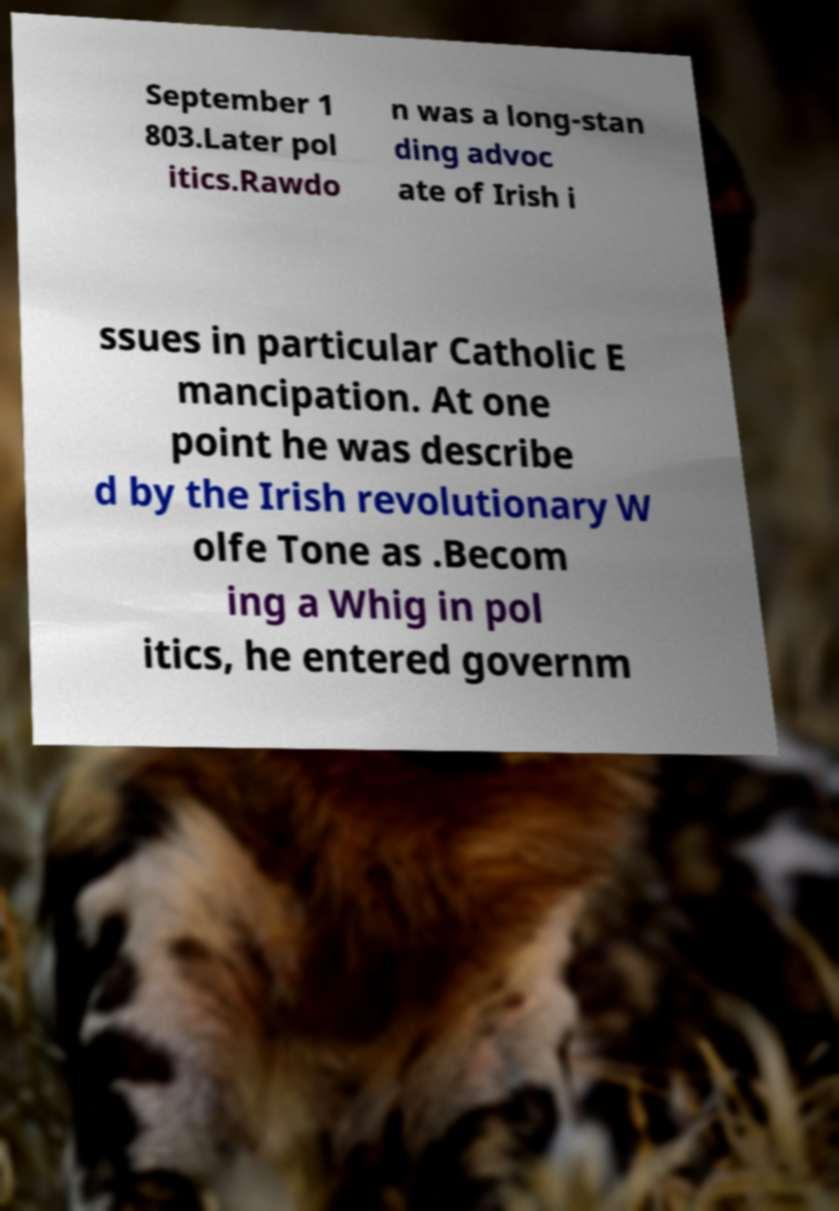For documentation purposes, I need the text within this image transcribed. Could you provide that? September 1 803.Later pol itics.Rawdo n was a long-stan ding advoc ate of Irish i ssues in particular Catholic E mancipation. At one point he was describe d by the Irish revolutionary W olfe Tone as .Becom ing a Whig in pol itics, he entered governm 